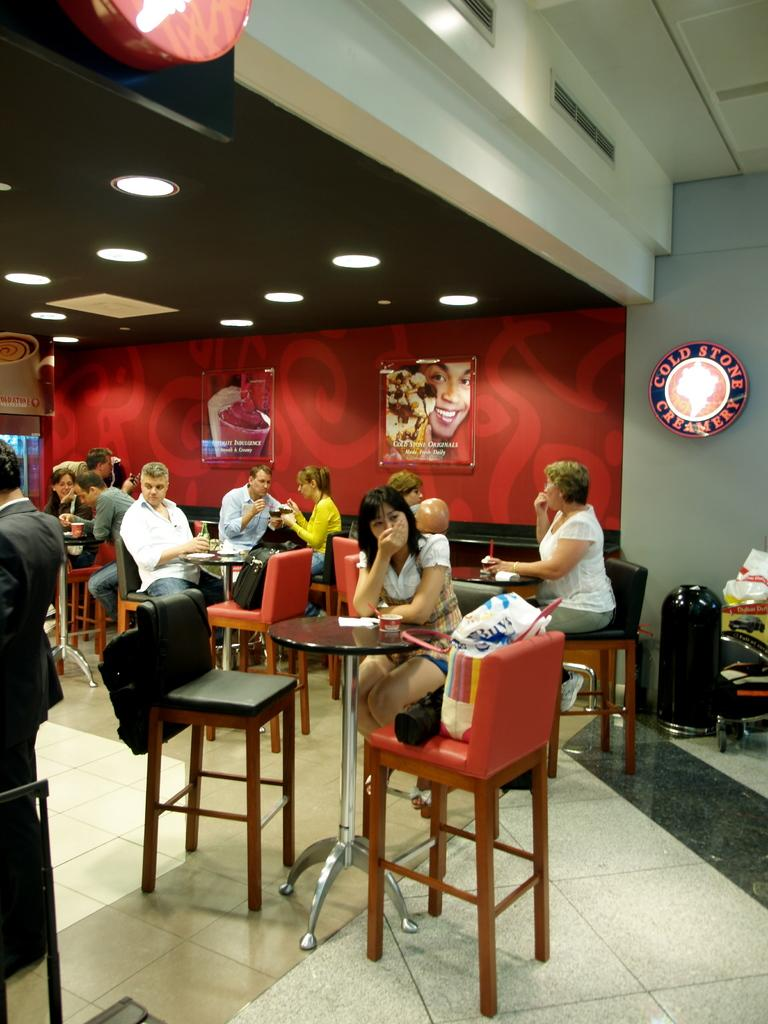What is happening in the image? There is a group of people in the image. How are the people positioned in the image? The people are seated on chairs. What can be seen on the wall in the image? There are frames on the wall in the image. What type of winter treatment is being administered to the people in the image? There is no indication of winter or any treatment in the image; it simply shows a group of people seated on chairs with frames on the wall. 